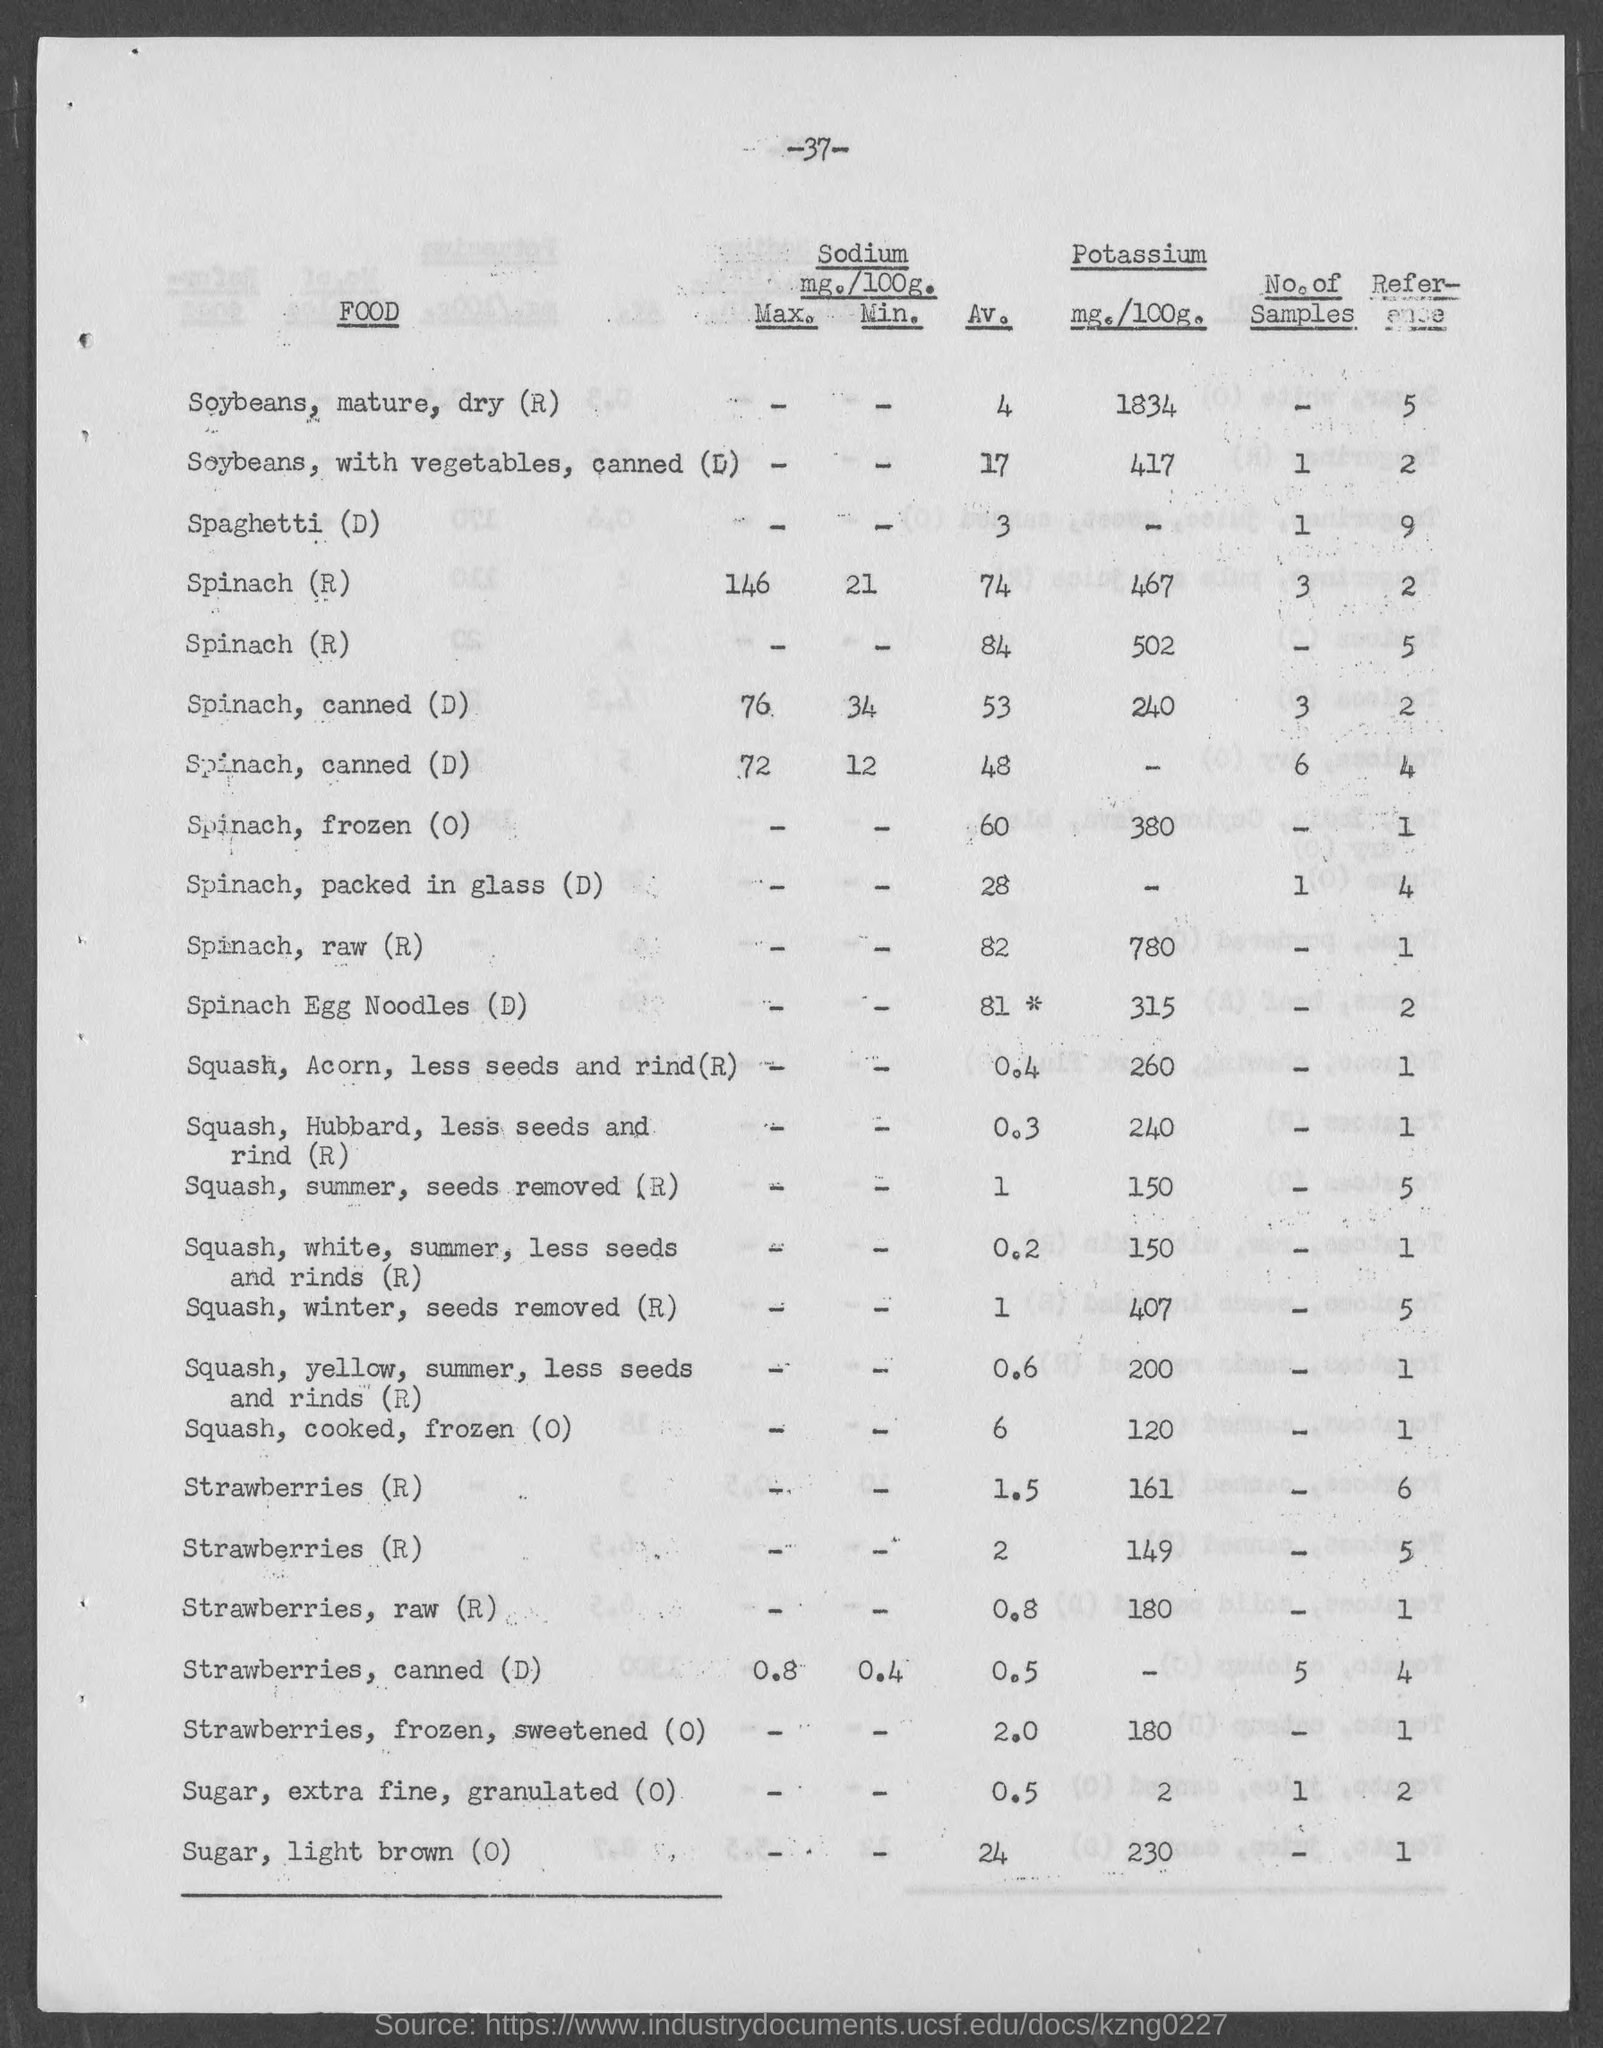Are there any other nutrients in winter squash that are beneficial to health? Winter squash is not only a good source of Potassium but also rich in vitamins like Vitamin A and Vitamin C, dietary fiber, and antioxidants. These nutrients support vision health, immune function, and digestive health. 